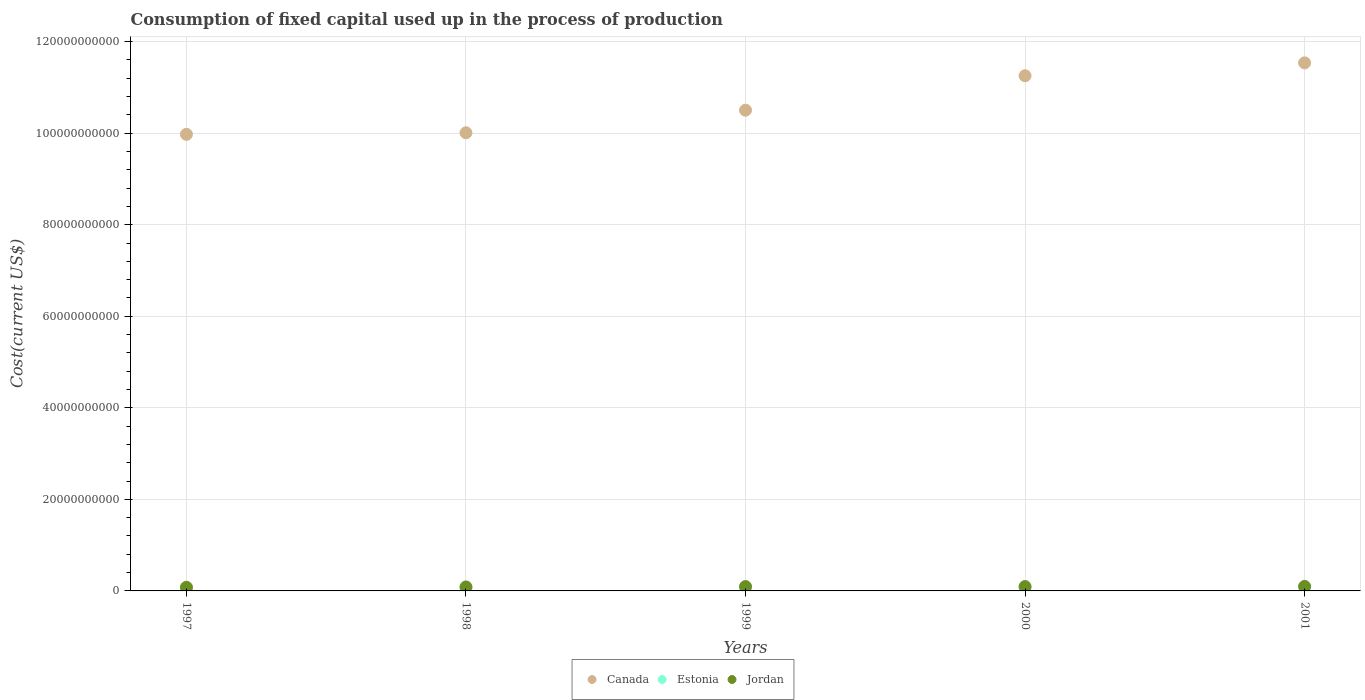How many different coloured dotlines are there?
Provide a short and direct response. 3. What is the amount consumed in the process of production in Canada in 2001?
Make the answer very short. 1.15e+11. Across all years, what is the maximum amount consumed in the process of production in Canada?
Offer a very short reply. 1.15e+11. Across all years, what is the minimum amount consumed in the process of production in Jordan?
Your answer should be compact. 7.96e+08. In which year was the amount consumed in the process of production in Jordan maximum?
Provide a short and direct response. 2001. What is the total amount consumed in the process of production in Canada in the graph?
Your answer should be very brief. 5.33e+11. What is the difference between the amount consumed in the process of production in Canada in 1997 and that in 2001?
Your answer should be very brief. -1.56e+1. What is the difference between the amount consumed in the process of production in Canada in 1997 and the amount consumed in the process of production in Estonia in 2001?
Provide a short and direct response. 9.90e+1. What is the average amount consumed in the process of production in Jordan per year?
Make the answer very short. 9.11e+08. In the year 2001, what is the difference between the amount consumed in the process of production in Canada and amount consumed in the process of production in Estonia?
Your answer should be very brief. 1.15e+11. In how many years, is the amount consumed in the process of production in Estonia greater than 12000000000 US$?
Ensure brevity in your answer.  0. What is the ratio of the amount consumed in the process of production in Estonia in 1999 to that in 2001?
Your answer should be compact. 0.9. Is the amount consumed in the process of production in Canada in 1998 less than that in 2000?
Provide a short and direct response. Yes. What is the difference between the highest and the second highest amount consumed in the process of production in Canada?
Offer a terse response. 2.82e+09. What is the difference between the highest and the lowest amount consumed in the process of production in Canada?
Your response must be concise. 1.56e+1. In how many years, is the amount consumed in the process of production in Jordan greater than the average amount consumed in the process of production in Jordan taken over all years?
Keep it short and to the point. 3. Is it the case that in every year, the sum of the amount consumed in the process of production in Estonia and amount consumed in the process of production in Jordan  is greater than the amount consumed in the process of production in Canada?
Make the answer very short. No. Does the amount consumed in the process of production in Estonia monotonically increase over the years?
Keep it short and to the point. No. How many dotlines are there?
Offer a very short reply. 3. How many years are there in the graph?
Ensure brevity in your answer.  5. Where does the legend appear in the graph?
Ensure brevity in your answer.  Bottom center. How are the legend labels stacked?
Provide a short and direct response. Horizontal. What is the title of the graph?
Make the answer very short. Consumption of fixed capital used up in the process of production. Does "Indonesia" appear as one of the legend labels in the graph?
Keep it short and to the point. No. What is the label or title of the X-axis?
Give a very brief answer. Years. What is the label or title of the Y-axis?
Provide a short and direct response. Cost(current US$). What is the Cost(current US$) in Canada in 1997?
Your answer should be compact. 9.98e+1. What is the Cost(current US$) of Estonia in 1997?
Offer a terse response. 5.56e+08. What is the Cost(current US$) of Jordan in 1997?
Offer a very short reply. 7.96e+08. What is the Cost(current US$) in Canada in 1998?
Your answer should be very brief. 1.00e+11. What is the Cost(current US$) in Estonia in 1998?
Provide a succinct answer. 6.23e+08. What is the Cost(current US$) of Jordan in 1998?
Offer a very short reply. 8.69e+08. What is the Cost(current US$) in Canada in 1999?
Offer a very short reply. 1.05e+11. What is the Cost(current US$) of Estonia in 1999?
Give a very brief answer. 6.82e+08. What is the Cost(current US$) of Jordan in 1999?
Your answer should be compact. 9.53e+08. What is the Cost(current US$) in Canada in 2000?
Keep it short and to the point. 1.13e+11. What is the Cost(current US$) in Estonia in 2000?
Make the answer very short. 6.70e+08. What is the Cost(current US$) of Jordan in 2000?
Your answer should be compact. 9.50e+08. What is the Cost(current US$) in Canada in 2001?
Offer a terse response. 1.15e+11. What is the Cost(current US$) in Estonia in 2001?
Give a very brief answer. 7.59e+08. What is the Cost(current US$) in Jordan in 2001?
Your answer should be very brief. 9.87e+08. Across all years, what is the maximum Cost(current US$) in Canada?
Keep it short and to the point. 1.15e+11. Across all years, what is the maximum Cost(current US$) of Estonia?
Keep it short and to the point. 7.59e+08. Across all years, what is the maximum Cost(current US$) of Jordan?
Your answer should be very brief. 9.87e+08. Across all years, what is the minimum Cost(current US$) in Canada?
Offer a terse response. 9.98e+1. Across all years, what is the minimum Cost(current US$) of Estonia?
Keep it short and to the point. 5.56e+08. Across all years, what is the minimum Cost(current US$) in Jordan?
Provide a short and direct response. 7.96e+08. What is the total Cost(current US$) in Canada in the graph?
Your answer should be very brief. 5.33e+11. What is the total Cost(current US$) in Estonia in the graph?
Make the answer very short. 3.29e+09. What is the total Cost(current US$) in Jordan in the graph?
Offer a very short reply. 4.56e+09. What is the difference between the Cost(current US$) in Canada in 1997 and that in 1998?
Make the answer very short. -3.42e+08. What is the difference between the Cost(current US$) in Estonia in 1997 and that in 1998?
Provide a short and direct response. -6.69e+07. What is the difference between the Cost(current US$) in Jordan in 1997 and that in 1998?
Your response must be concise. -7.29e+07. What is the difference between the Cost(current US$) of Canada in 1997 and that in 1999?
Your answer should be very brief. -5.27e+09. What is the difference between the Cost(current US$) in Estonia in 1997 and that in 1999?
Keep it short and to the point. -1.25e+08. What is the difference between the Cost(current US$) in Jordan in 1997 and that in 1999?
Offer a terse response. -1.57e+08. What is the difference between the Cost(current US$) of Canada in 1997 and that in 2000?
Provide a short and direct response. -1.28e+1. What is the difference between the Cost(current US$) in Estonia in 1997 and that in 2000?
Your response must be concise. -1.14e+08. What is the difference between the Cost(current US$) in Jordan in 1997 and that in 2000?
Offer a terse response. -1.54e+08. What is the difference between the Cost(current US$) of Canada in 1997 and that in 2001?
Offer a terse response. -1.56e+1. What is the difference between the Cost(current US$) in Estonia in 1997 and that in 2001?
Your answer should be very brief. -2.03e+08. What is the difference between the Cost(current US$) of Jordan in 1997 and that in 2001?
Offer a terse response. -1.91e+08. What is the difference between the Cost(current US$) of Canada in 1998 and that in 1999?
Give a very brief answer. -4.93e+09. What is the difference between the Cost(current US$) in Estonia in 1998 and that in 1999?
Keep it short and to the point. -5.84e+07. What is the difference between the Cost(current US$) of Jordan in 1998 and that in 1999?
Make the answer very short. -8.41e+07. What is the difference between the Cost(current US$) of Canada in 1998 and that in 2000?
Your answer should be compact. -1.25e+1. What is the difference between the Cost(current US$) in Estonia in 1998 and that in 2000?
Offer a terse response. -4.69e+07. What is the difference between the Cost(current US$) of Jordan in 1998 and that in 2000?
Keep it short and to the point. -8.07e+07. What is the difference between the Cost(current US$) of Canada in 1998 and that in 2001?
Make the answer very short. -1.53e+1. What is the difference between the Cost(current US$) of Estonia in 1998 and that in 2001?
Your response must be concise. -1.36e+08. What is the difference between the Cost(current US$) in Jordan in 1998 and that in 2001?
Make the answer very short. -1.19e+08. What is the difference between the Cost(current US$) of Canada in 1999 and that in 2000?
Make the answer very short. -7.52e+09. What is the difference between the Cost(current US$) of Estonia in 1999 and that in 2000?
Provide a short and direct response. 1.15e+07. What is the difference between the Cost(current US$) of Jordan in 1999 and that in 2000?
Provide a short and direct response. 3.34e+06. What is the difference between the Cost(current US$) in Canada in 1999 and that in 2001?
Offer a terse response. -1.03e+1. What is the difference between the Cost(current US$) of Estonia in 1999 and that in 2001?
Your response must be concise. -7.73e+07. What is the difference between the Cost(current US$) in Jordan in 1999 and that in 2001?
Offer a terse response. -3.45e+07. What is the difference between the Cost(current US$) of Canada in 2000 and that in 2001?
Offer a very short reply. -2.82e+09. What is the difference between the Cost(current US$) of Estonia in 2000 and that in 2001?
Offer a terse response. -8.88e+07. What is the difference between the Cost(current US$) in Jordan in 2000 and that in 2001?
Offer a terse response. -3.78e+07. What is the difference between the Cost(current US$) in Canada in 1997 and the Cost(current US$) in Estonia in 1998?
Offer a terse response. 9.91e+1. What is the difference between the Cost(current US$) in Canada in 1997 and the Cost(current US$) in Jordan in 1998?
Offer a very short reply. 9.89e+1. What is the difference between the Cost(current US$) in Estonia in 1997 and the Cost(current US$) in Jordan in 1998?
Offer a terse response. -3.12e+08. What is the difference between the Cost(current US$) of Canada in 1997 and the Cost(current US$) of Estonia in 1999?
Provide a short and direct response. 9.91e+1. What is the difference between the Cost(current US$) of Canada in 1997 and the Cost(current US$) of Jordan in 1999?
Your answer should be compact. 9.88e+1. What is the difference between the Cost(current US$) in Estonia in 1997 and the Cost(current US$) in Jordan in 1999?
Provide a succinct answer. -3.96e+08. What is the difference between the Cost(current US$) in Canada in 1997 and the Cost(current US$) in Estonia in 2000?
Offer a very short reply. 9.91e+1. What is the difference between the Cost(current US$) in Canada in 1997 and the Cost(current US$) in Jordan in 2000?
Your response must be concise. 9.88e+1. What is the difference between the Cost(current US$) in Estonia in 1997 and the Cost(current US$) in Jordan in 2000?
Ensure brevity in your answer.  -3.93e+08. What is the difference between the Cost(current US$) in Canada in 1997 and the Cost(current US$) in Estonia in 2001?
Your answer should be compact. 9.90e+1. What is the difference between the Cost(current US$) in Canada in 1997 and the Cost(current US$) in Jordan in 2001?
Make the answer very short. 9.88e+1. What is the difference between the Cost(current US$) of Estonia in 1997 and the Cost(current US$) of Jordan in 2001?
Make the answer very short. -4.31e+08. What is the difference between the Cost(current US$) of Canada in 1998 and the Cost(current US$) of Estonia in 1999?
Your response must be concise. 9.94e+1. What is the difference between the Cost(current US$) in Canada in 1998 and the Cost(current US$) in Jordan in 1999?
Keep it short and to the point. 9.92e+1. What is the difference between the Cost(current US$) of Estonia in 1998 and the Cost(current US$) of Jordan in 1999?
Offer a terse response. -3.30e+08. What is the difference between the Cost(current US$) of Canada in 1998 and the Cost(current US$) of Estonia in 2000?
Give a very brief answer. 9.94e+1. What is the difference between the Cost(current US$) of Canada in 1998 and the Cost(current US$) of Jordan in 2000?
Your answer should be compact. 9.92e+1. What is the difference between the Cost(current US$) of Estonia in 1998 and the Cost(current US$) of Jordan in 2000?
Your answer should be very brief. -3.26e+08. What is the difference between the Cost(current US$) of Canada in 1998 and the Cost(current US$) of Estonia in 2001?
Provide a short and direct response. 9.93e+1. What is the difference between the Cost(current US$) of Canada in 1998 and the Cost(current US$) of Jordan in 2001?
Provide a succinct answer. 9.91e+1. What is the difference between the Cost(current US$) of Estonia in 1998 and the Cost(current US$) of Jordan in 2001?
Ensure brevity in your answer.  -3.64e+08. What is the difference between the Cost(current US$) of Canada in 1999 and the Cost(current US$) of Estonia in 2000?
Offer a terse response. 1.04e+11. What is the difference between the Cost(current US$) of Canada in 1999 and the Cost(current US$) of Jordan in 2000?
Offer a terse response. 1.04e+11. What is the difference between the Cost(current US$) in Estonia in 1999 and the Cost(current US$) in Jordan in 2000?
Make the answer very short. -2.68e+08. What is the difference between the Cost(current US$) of Canada in 1999 and the Cost(current US$) of Estonia in 2001?
Provide a short and direct response. 1.04e+11. What is the difference between the Cost(current US$) in Canada in 1999 and the Cost(current US$) in Jordan in 2001?
Your answer should be very brief. 1.04e+11. What is the difference between the Cost(current US$) in Estonia in 1999 and the Cost(current US$) in Jordan in 2001?
Your response must be concise. -3.06e+08. What is the difference between the Cost(current US$) of Canada in 2000 and the Cost(current US$) of Estonia in 2001?
Your answer should be compact. 1.12e+11. What is the difference between the Cost(current US$) in Canada in 2000 and the Cost(current US$) in Jordan in 2001?
Make the answer very short. 1.12e+11. What is the difference between the Cost(current US$) in Estonia in 2000 and the Cost(current US$) in Jordan in 2001?
Your response must be concise. -3.17e+08. What is the average Cost(current US$) of Canada per year?
Offer a terse response. 1.07e+11. What is the average Cost(current US$) in Estonia per year?
Your answer should be compact. 6.58e+08. What is the average Cost(current US$) of Jordan per year?
Ensure brevity in your answer.  9.11e+08. In the year 1997, what is the difference between the Cost(current US$) of Canada and Cost(current US$) of Estonia?
Ensure brevity in your answer.  9.92e+1. In the year 1997, what is the difference between the Cost(current US$) of Canada and Cost(current US$) of Jordan?
Give a very brief answer. 9.90e+1. In the year 1997, what is the difference between the Cost(current US$) of Estonia and Cost(current US$) of Jordan?
Ensure brevity in your answer.  -2.40e+08. In the year 1998, what is the difference between the Cost(current US$) of Canada and Cost(current US$) of Estonia?
Offer a very short reply. 9.95e+1. In the year 1998, what is the difference between the Cost(current US$) in Canada and Cost(current US$) in Jordan?
Your answer should be compact. 9.92e+1. In the year 1998, what is the difference between the Cost(current US$) of Estonia and Cost(current US$) of Jordan?
Offer a very short reply. -2.46e+08. In the year 1999, what is the difference between the Cost(current US$) of Canada and Cost(current US$) of Estonia?
Provide a succinct answer. 1.04e+11. In the year 1999, what is the difference between the Cost(current US$) in Canada and Cost(current US$) in Jordan?
Offer a very short reply. 1.04e+11. In the year 1999, what is the difference between the Cost(current US$) of Estonia and Cost(current US$) of Jordan?
Make the answer very short. -2.71e+08. In the year 2000, what is the difference between the Cost(current US$) in Canada and Cost(current US$) in Estonia?
Provide a short and direct response. 1.12e+11. In the year 2000, what is the difference between the Cost(current US$) of Canada and Cost(current US$) of Jordan?
Your response must be concise. 1.12e+11. In the year 2000, what is the difference between the Cost(current US$) in Estonia and Cost(current US$) in Jordan?
Provide a succinct answer. -2.79e+08. In the year 2001, what is the difference between the Cost(current US$) of Canada and Cost(current US$) of Estonia?
Make the answer very short. 1.15e+11. In the year 2001, what is the difference between the Cost(current US$) in Canada and Cost(current US$) in Jordan?
Your answer should be very brief. 1.14e+11. In the year 2001, what is the difference between the Cost(current US$) in Estonia and Cost(current US$) in Jordan?
Provide a succinct answer. -2.28e+08. What is the ratio of the Cost(current US$) of Canada in 1997 to that in 1998?
Offer a very short reply. 1. What is the ratio of the Cost(current US$) of Estonia in 1997 to that in 1998?
Offer a very short reply. 0.89. What is the ratio of the Cost(current US$) of Jordan in 1997 to that in 1998?
Your answer should be compact. 0.92. What is the ratio of the Cost(current US$) in Canada in 1997 to that in 1999?
Provide a short and direct response. 0.95. What is the ratio of the Cost(current US$) in Estonia in 1997 to that in 1999?
Keep it short and to the point. 0.82. What is the ratio of the Cost(current US$) in Jordan in 1997 to that in 1999?
Your response must be concise. 0.84. What is the ratio of the Cost(current US$) in Canada in 1997 to that in 2000?
Make the answer very short. 0.89. What is the ratio of the Cost(current US$) in Estonia in 1997 to that in 2000?
Give a very brief answer. 0.83. What is the ratio of the Cost(current US$) of Jordan in 1997 to that in 2000?
Give a very brief answer. 0.84. What is the ratio of the Cost(current US$) in Canada in 1997 to that in 2001?
Provide a short and direct response. 0.86. What is the ratio of the Cost(current US$) of Estonia in 1997 to that in 2001?
Provide a short and direct response. 0.73. What is the ratio of the Cost(current US$) in Jordan in 1997 to that in 2001?
Keep it short and to the point. 0.81. What is the ratio of the Cost(current US$) of Canada in 1998 to that in 1999?
Provide a succinct answer. 0.95. What is the ratio of the Cost(current US$) of Estonia in 1998 to that in 1999?
Provide a succinct answer. 0.91. What is the ratio of the Cost(current US$) of Jordan in 1998 to that in 1999?
Offer a very short reply. 0.91. What is the ratio of the Cost(current US$) of Canada in 1998 to that in 2000?
Provide a short and direct response. 0.89. What is the ratio of the Cost(current US$) of Estonia in 1998 to that in 2000?
Offer a terse response. 0.93. What is the ratio of the Cost(current US$) in Jordan in 1998 to that in 2000?
Provide a succinct answer. 0.92. What is the ratio of the Cost(current US$) of Canada in 1998 to that in 2001?
Offer a terse response. 0.87. What is the ratio of the Cost(current US$) of Estonia in 1998 to that in 2001?
Your answer should be compact. 0.82. What is the ratio of the Cost(current US$) in Jordan in 1998 to that in 2001?
Give a very brief answer. 0.88. What is the ratio of the Cost(current US$) of Canada in 1999 to that in 2000?
Your answer should be compact. 0.93. What is the ratio of the Cost(current US$) of Estonia in 1999 to that in 2000?
Give a very brief answer. 1.02. What is the ratio of the Cost(current US$) of Canada in 1999 to that in 2001?
Your answer should be very brief. 0.91. What is the ratio of the Cost(current US$) in Estonia in 1999 to that in 2001?
Your answer should be compact. 0.9. What is the ratio of the Cost(current US$) of Jordan in 1999 to that in 2001?
Offer a very short reply. 0.97. What is the ratio of the Cost(current US$) in Canada in 2000 to that in 2001?
Give a very brief answer. 0.98. What is the ratio of the Cost(current US$) of Estonia in 2000 to that in 2001?
Your answer should be very brief. 0.88. What is the ratio of the Cost(current US$) of Jordan in 2000 to that in 2001?
Your response must be concise. 0.96. What is the difference between the highest and the second highest Cost(current US$) in Canada?
Your answer should be very brief. 2.82e+09. What is the difference between the highest and the second highest Cost(current US$) in Estonia?
Offer a terse response. 7.73e+07. What is the difference between the highest and the second highest Cost(current US$) in Jordan?
Your answer should be very brief. 3.45e+07. What is the difference between the highest and the lowest Cost(current US$) of Canada?
Ensure brevity in your answer.  1.56e+1. What is the difference between the highest and the lowest Cost(current US$) in Estonia?
Provide a succinct answer. 2.03e+08. What is the difference between the highest and the lowest Cost(current US$) of Jordan?
Offer a very short reply. 1.91e+08. 